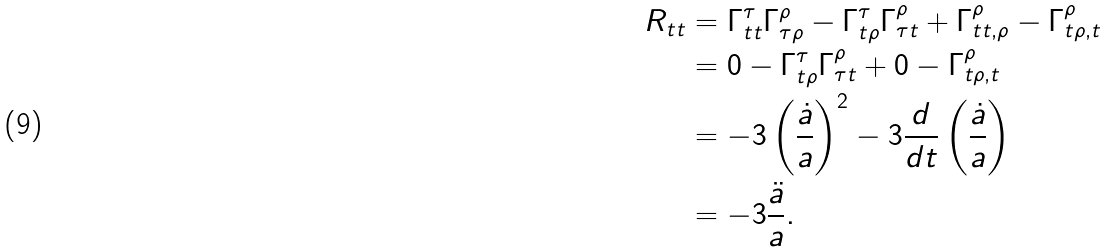<formula> <loc_0><loc_0><loc_500><loc_500>R _ { t t } & = \Gamma _ { t t } ^ { \tau } \Gamma _ { \tau \rho } ^ { \rho } - \Gamma _ { t \rho } ^ { \tau } \Gamma _ { \tau t } ^ { \rho } + \Gamma _ { t t , \rho } ^ { \rho } - \Gamma _ { t \rho , t } ^ { \rho } \\ & = 0 - \Gamma _ { t \rho } ^ { \tau } \Gamma _ { \tau t } ^ { \rho } + 0 - \Gamma _ { t \rho , t } ^ { \rho } \\ & = - 3 \left ( \frac { \dot { a } } { a } \right ) ^ { 2 } - 3 \frac { d } { d t } \left ( \frac { \dot { a } } { a } \right ) \\ & = - 3 \frac { \ddot { a } } { a } .</formula> 